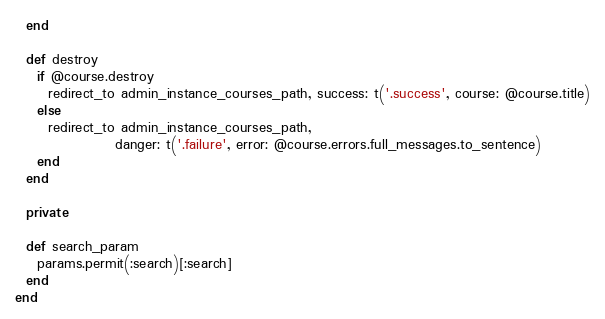<code> <loc_0><loc_0><loc_500><loc_500><_Ruby_>  end

  def destroy
    if @course.destroy
      redirect_to admin_instance_courses_path, success: t('.success', course: @course.title)
    else
      redirect_to admin_instance_courses_path,
                  danger: t('.failure', error: @course.errors.full_messages.to_sentence)
    end
  end

  private

  def search_param
    params.permit(:search)[:search]
  end
end
</code> 